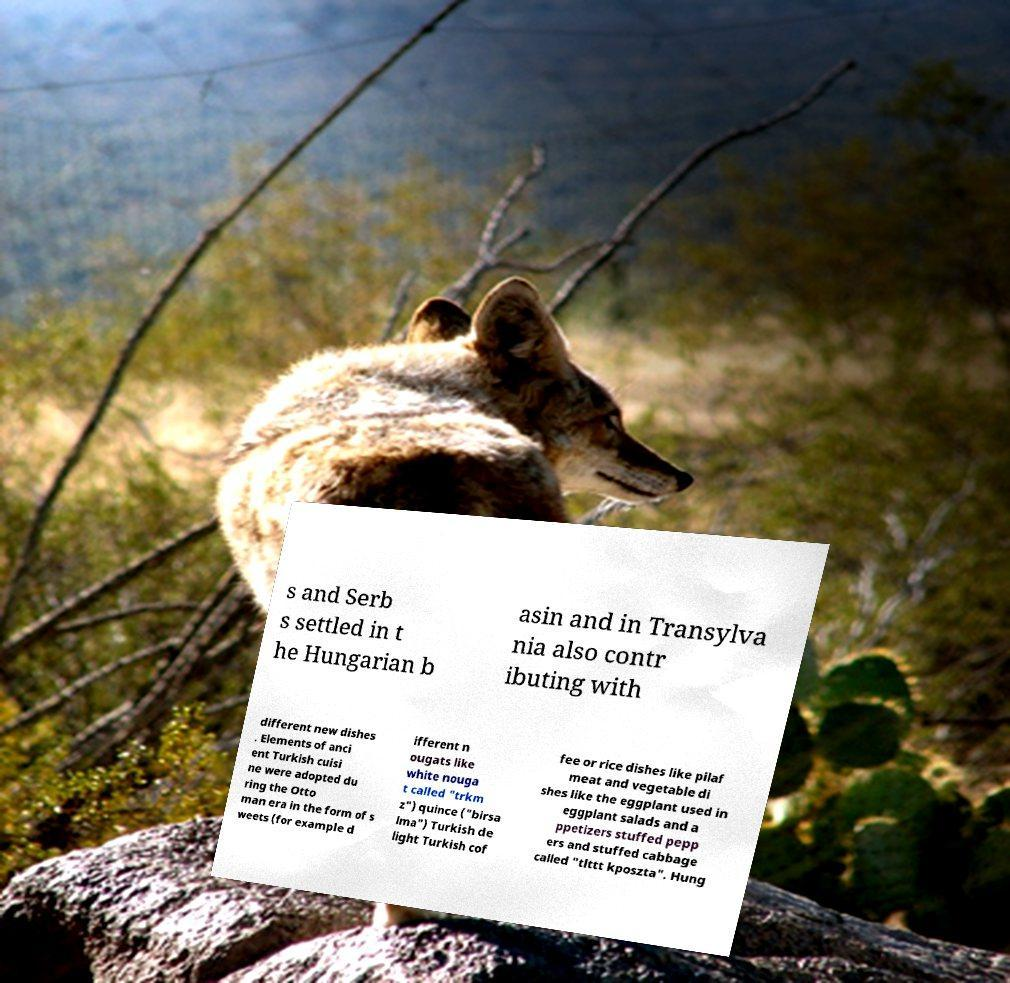What messages or text are displayed in this image? I need them in a readable, typed format. s and Serb s settled in t he Hungarian b asin and in Transylva nia also contr ibuting with different new dishes . Elements of anci ent Turkish cuisi ne were adopted du ring the Otto man era in the form of s weets (for example d ifferent n ougats like white nouga t called "trkm z") quince ("birsa lma") Turkish de light Turkish cof fee or rice dishes like pilaf meat and vegetable di shes like the eggplant used in eggplant salads and a ppetizers stuffed pepp ers and stuffed cabbage called "tlttt kposzta". Hung 